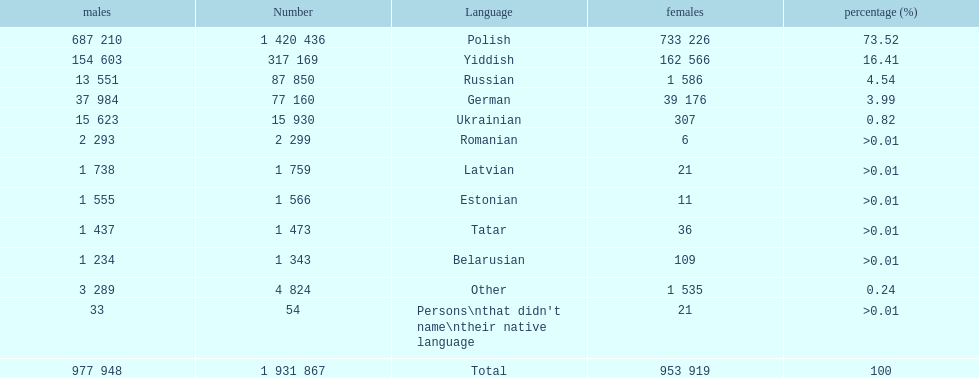What was the top language from the one's whose percentage was >0.01 Romanian. 